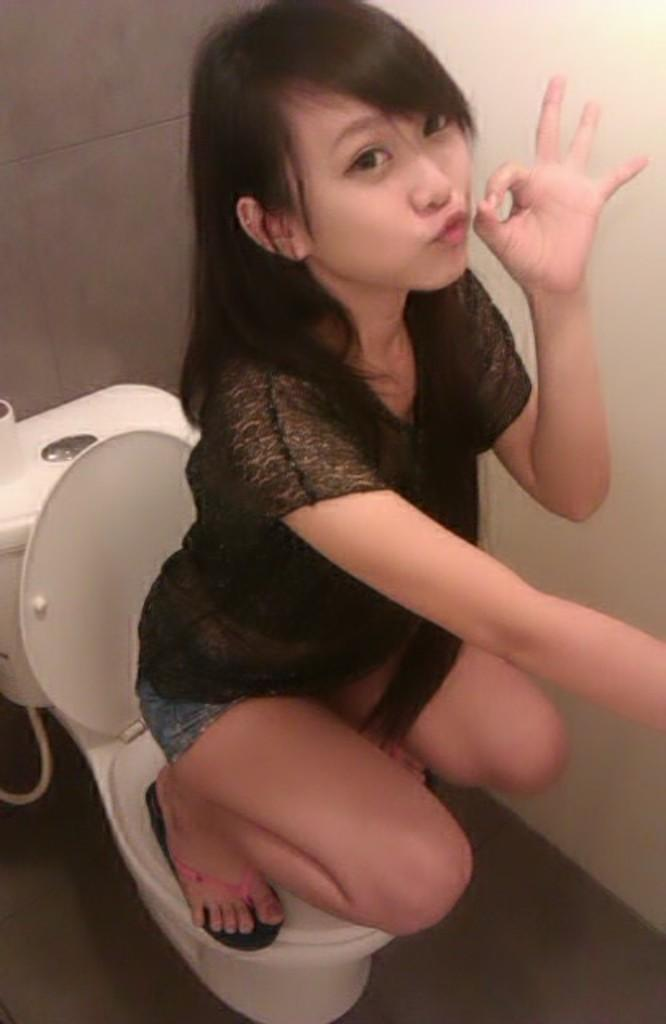Who is present in the image? There is a woman in the image. What is the woman wearing? The woman is wearing a black dress. What position is the woman in? The woman is sitting on the commode in a squat position. What can be seen in the background of the image? There is a flush tank and a wall in the background of the image. What is the amount of nut in the image? There is no nut present in the image, so it is not possible to determine the amount of nut. 